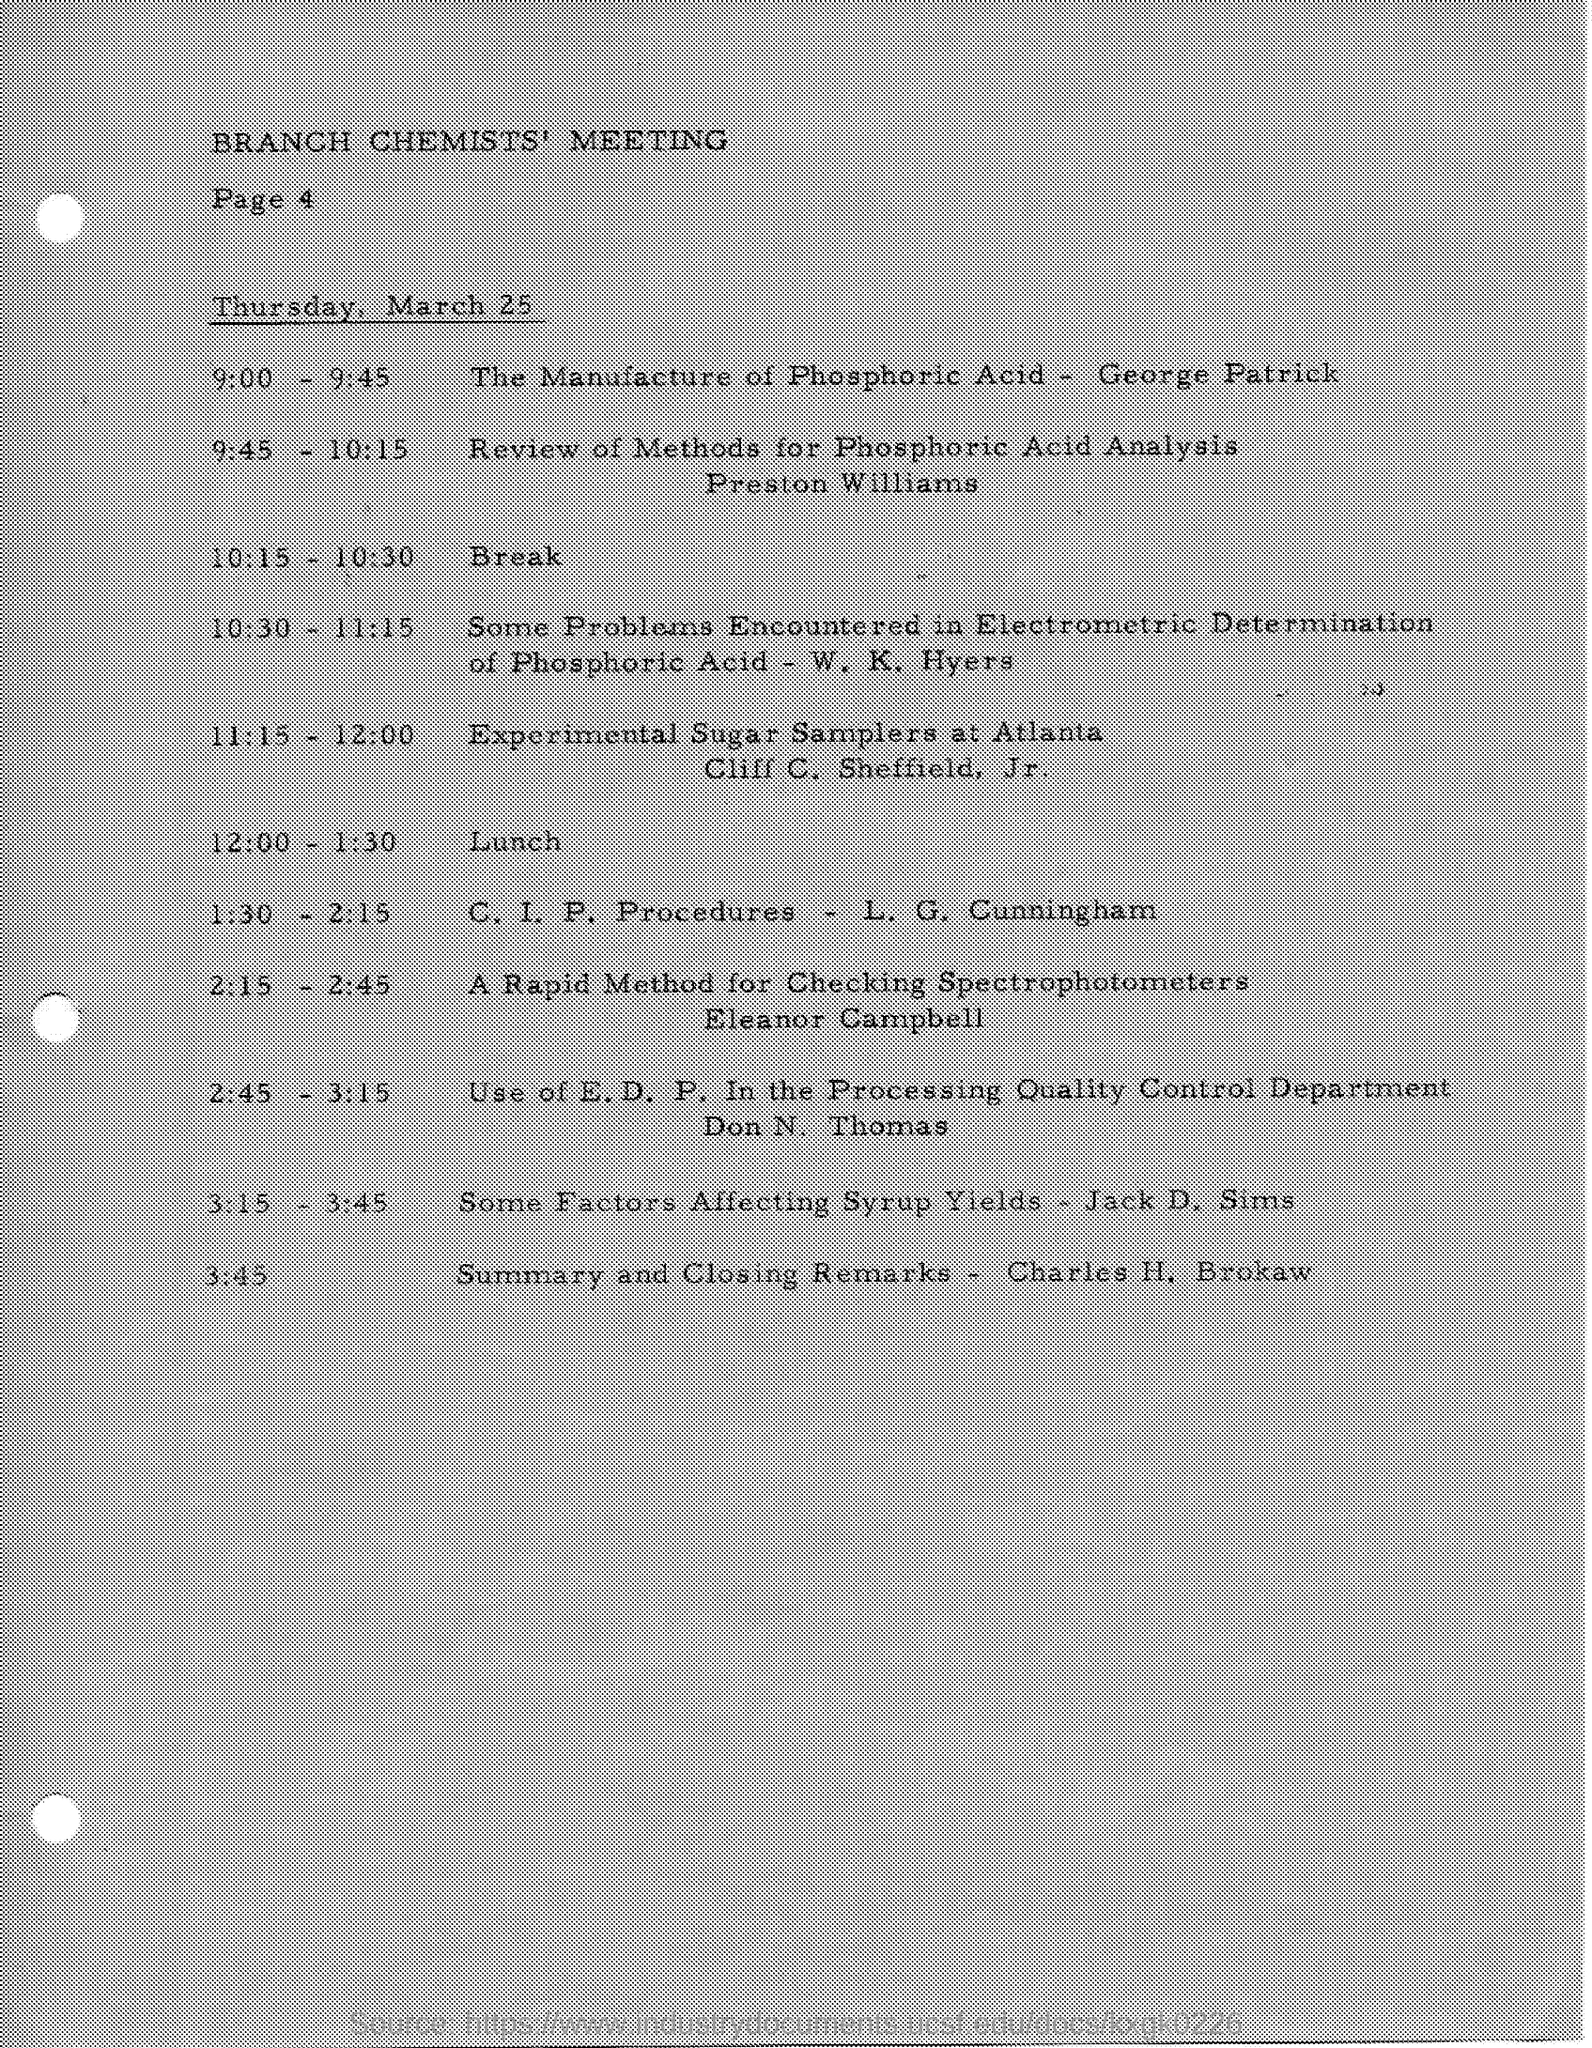What is the historical significance of phosphoric acid in industrial applications? Phosphoric acid has played a pivotal role in industrial applications due to its use in manufacturing fertilizers, animal feed, and various products in the food and beverage industry. Its properties as an acidity regulator and rust inhibitor also make it valuable in metal processing and refining. 